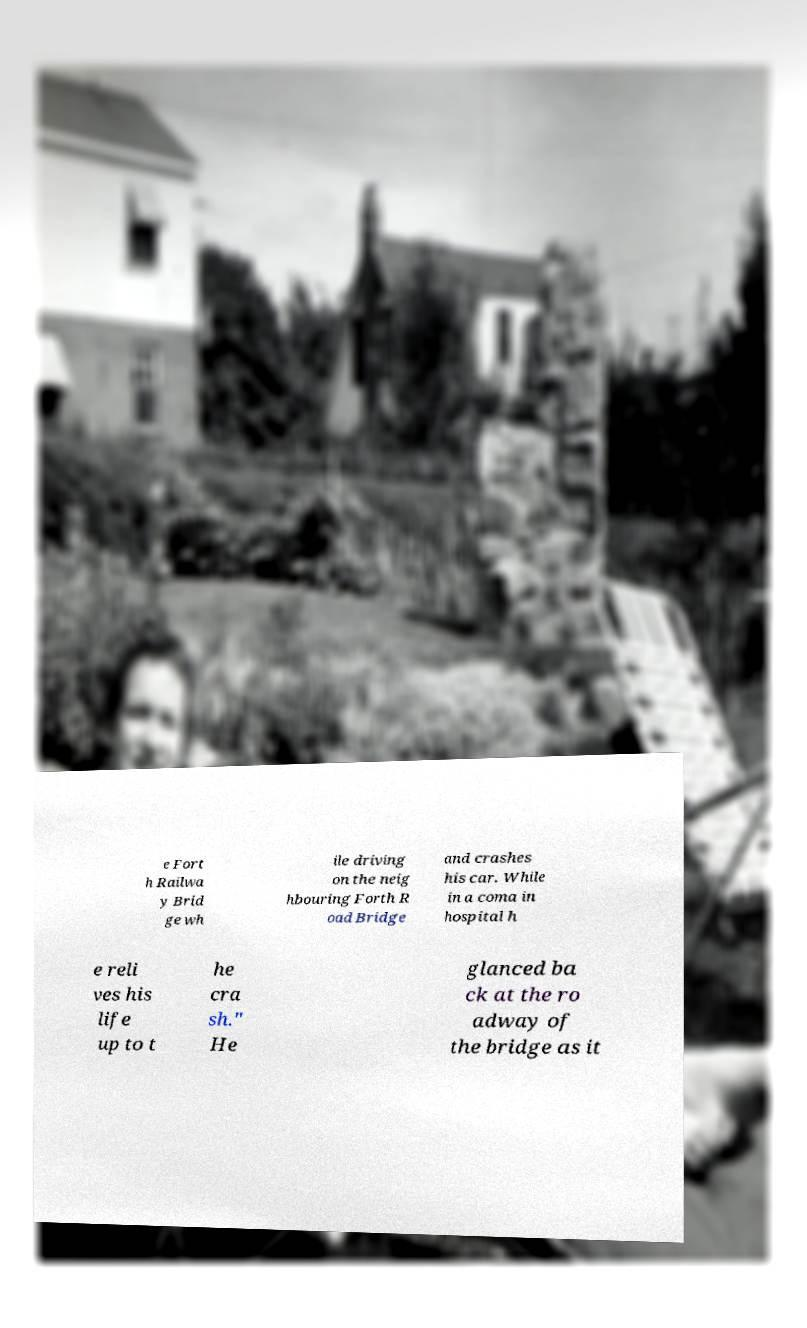Can you accurately transcribe the text from the provided image for me? e Fort h Railwa y Brid ge wh ile driving on the neig hbouring Forth R oad Bridge and crashes his car. While in a coma in hospital h e reli ves his life up to t he cra sh." He glanced ba ck at the ro adway of the bridge as it 